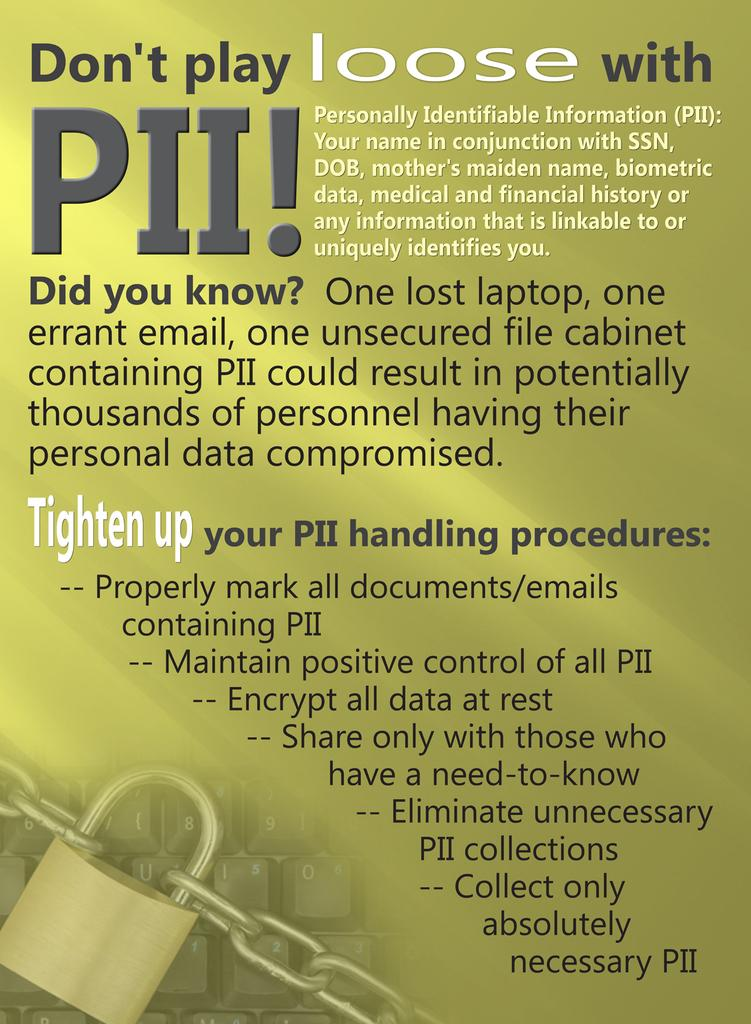<image>
Render a clear and concise summary of the photo. The poster warns you that one lost laptop could mean you compromising your personal data, 